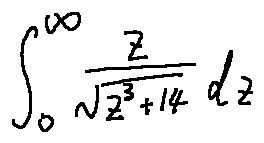Convert formula to latex. <formula><loc_0><loc_0><loc_500><loc_500>\int \lim i t s _ { 0 } ^ { \infty } \frac { z } { \sqrt { z ^ { 3 } + 1 4 } } d z</formula> 